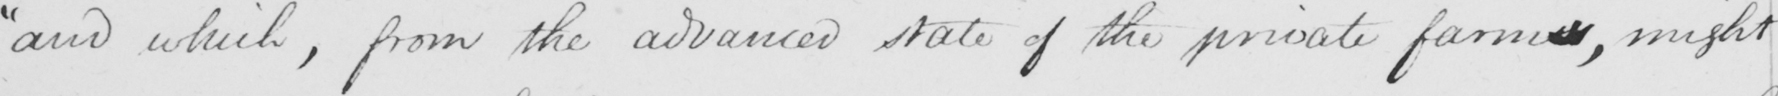Please provide the text content of this handwritten line. "and which, from the advanced state of the private farmers, might 